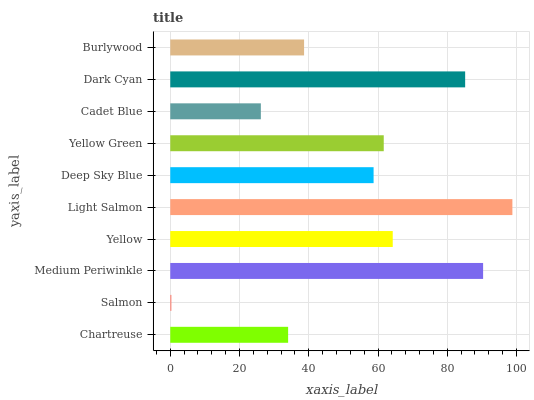Is Salmon the minimum?
Answer yes or no. Yes. Is Light Salmon the maximum?
Answer yes or no. Yes. Is Medium Periwinkle the minimum?
Answer yes or no. No. Is Medium Periwinkle the maximum?
Answer yes or no. No. Is Medium Periwinkle greater than Salmon?
Answer yes or no. Yes. Is Salmon less than Medium Periwinkle?
Answer yes or no. Yes. Is Salmon greater than Medium Periwinkle?
Answer yes or no. No. Is Medium Periwinkle less than Salmon?
Answer yes or no. No. Is Yellow Green the high median?
Answer yes or no. Yes. Is Deep Sky Blue the low median?
Answer yes or no. Yes. Is Yellow the high median?
Answer yes or no. No. Is Salmon the low median?
Answer yes or no. No. 